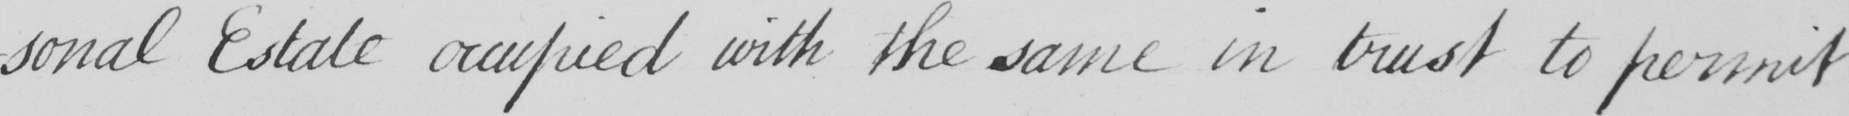What is written in this line of handwriting? -sonal Estate occupied with the same in trust to permit 